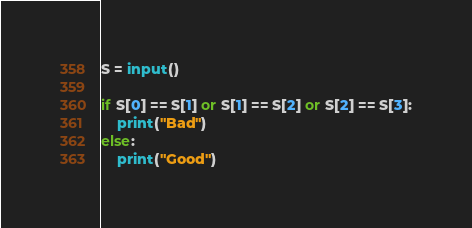<code> <loc_0><loc_0><loc_500><loc_500><_Python_>S = input()

if S[0] == S[1] or S[1] == S[2] or S[2] == S[3]:
    print("Bad")
else:
    print("Good")
</code> 